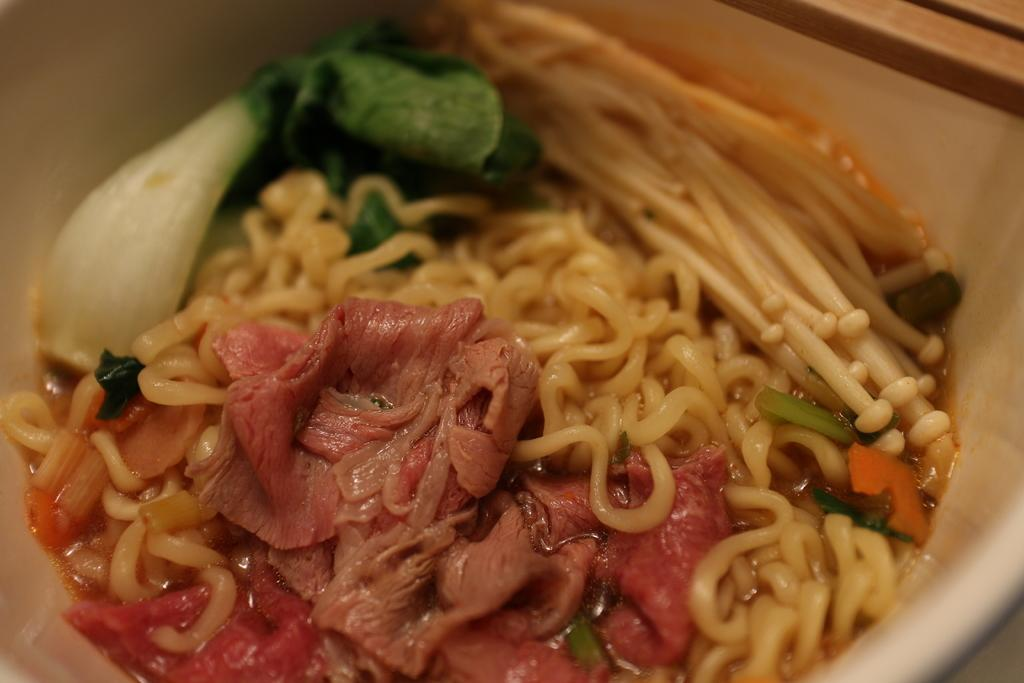What piece of furniture is present in the image? There is a table in the image. What is placed on the table? There is a bowl on the table. What is inside the bowl? The bowl contains food. How does the table contribute to the acoustics of the room in the image? The table does not contribute to the acoustics of the room in the image, as the provided facts do not mention any sound-related information. 